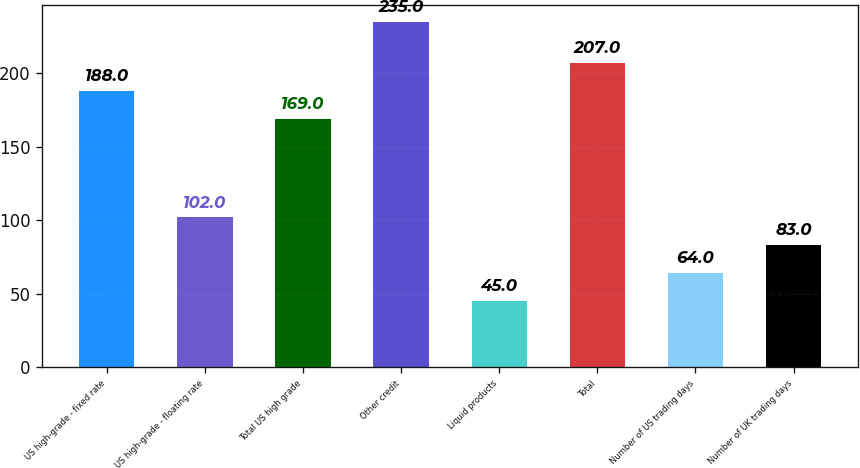Convert chart to OTSL. <chart><loc_0><loc_0><loc_500><loc_500><bar_chart><fcel>US high-grade - fixed rate<fcel>US high-grade - floating rate<fcel>Total US high grade<fcel>Other credit<fcel>Liquid products<fcel>Total<fcel>Number of US trading days<fcel>Number of UK trading days<nl><fcel>188<fcel>102<fcel>169<fcel>235<fcel>45<fcel>207<fcel>64<fcel>83<nl></chart> 